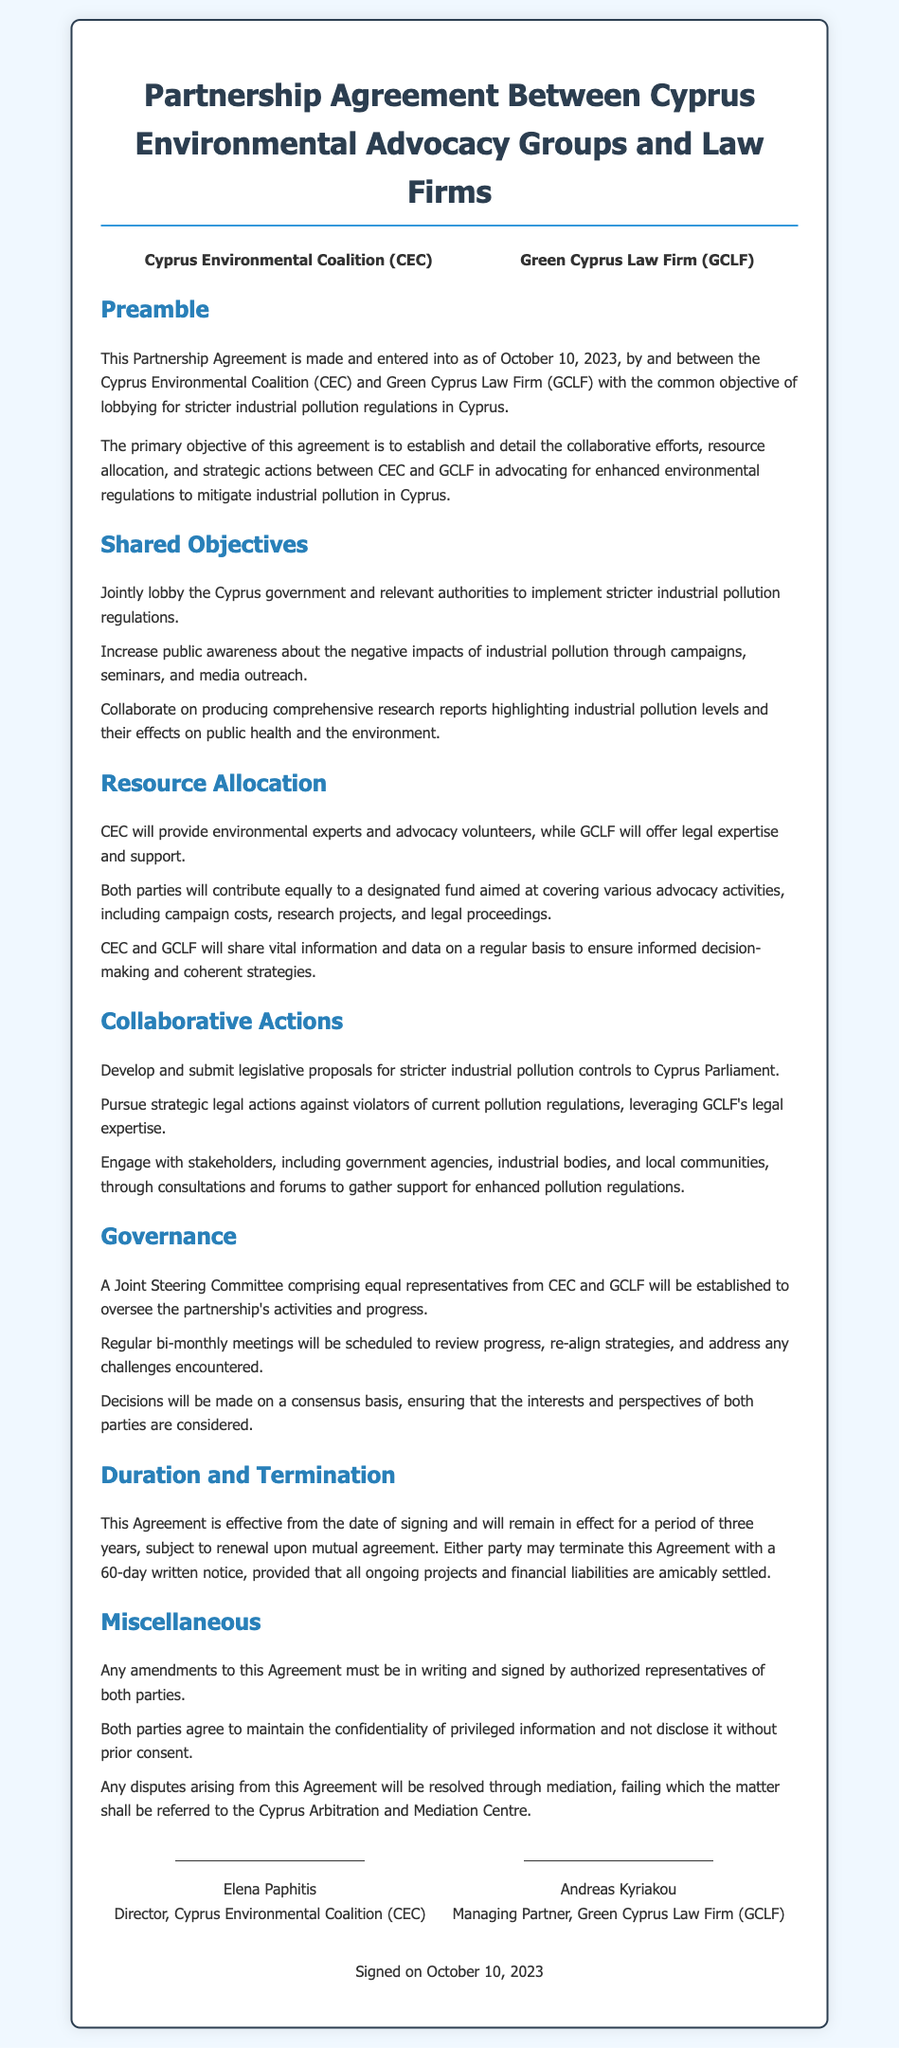What is the title of the agreement? The title of the agreement is presented at the top of the document.
Answer: Partnership Agreement Between Cyprus Environmental Advocacy Groups and Law Firms Who are the parties involved in the agreement? The parties are listed in a specific section of the document.
Answer: Cyprus Environmental Coalition (CEC) and Green Cyprus Law Firm (GCLF) When was the contract signed? The date of signing is mentioned in the preamble section.
Answer: October 10, 2023 How long is the effective duration of this agreement? The duration of the agreement is explicitly stated in the contract.
Answer: Three years What type of committee is established for overseeing activities? The type of committee is outlined in the governance section.
Answer: Joint Steering Committee What will CEC provide according to resource allocation? The specific resources CEC will provide are mentioned in the resource allocation section.
Answer: Environmental experts and advocacy volunteers What is required for termination of the agreement? The termination requirements are detailed in the duration and termination section.
Answer: 60-day written notice Which legal institution is mentioned for dispute resolution? The specific institution for resolving disputes is mentioned in the miscellaneous section.
Answer: Cyprus Arbitration and Mediation Centre How often will the committees meet to review progress? The frequency of meetings is specified in the governance section.
Answer: Bi-monthly 